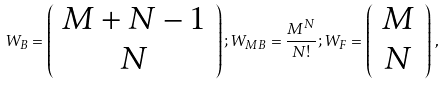<formula> <loc_0><loc_0><loc_500><loc_500>W _ { B } = \left ( \begin{array} { c } M + N - 1 \\ N \end{array} \right ) ; W _ { M B } = \frac { M ^ { N } } { N ! } ; W _ { F } = \left ( \begin{array} { c } M \\ N \end{array} \right ) \, ,</formula> 